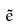<formula> <loc_0><loc_0><loc_500><loc_500>\tilde { e }</formula> 